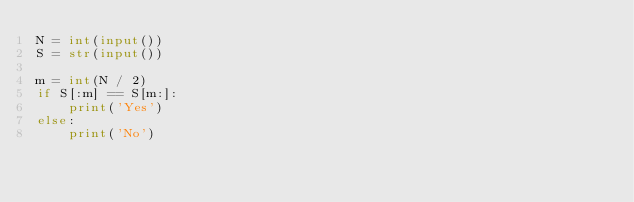Convert code to text. <code><loc_0><loc_0><loc_500><loc_500><_Python_>N = int(input())
S = str(input())

m = int(N / 2)
if S[:m] == S[m:]:
    print('Yes')
else:
    print('No')</code> 